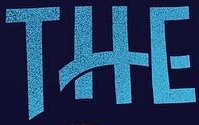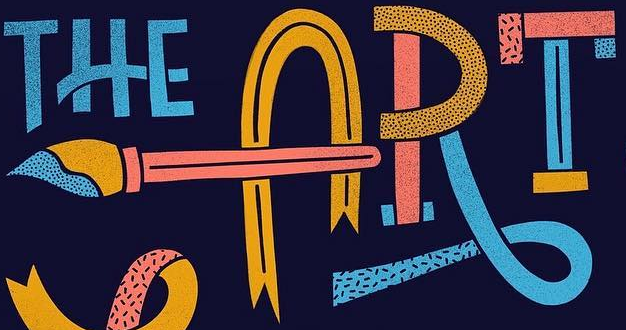What words can you see in these images in sequence, separated by a semicolon? THE; ART 